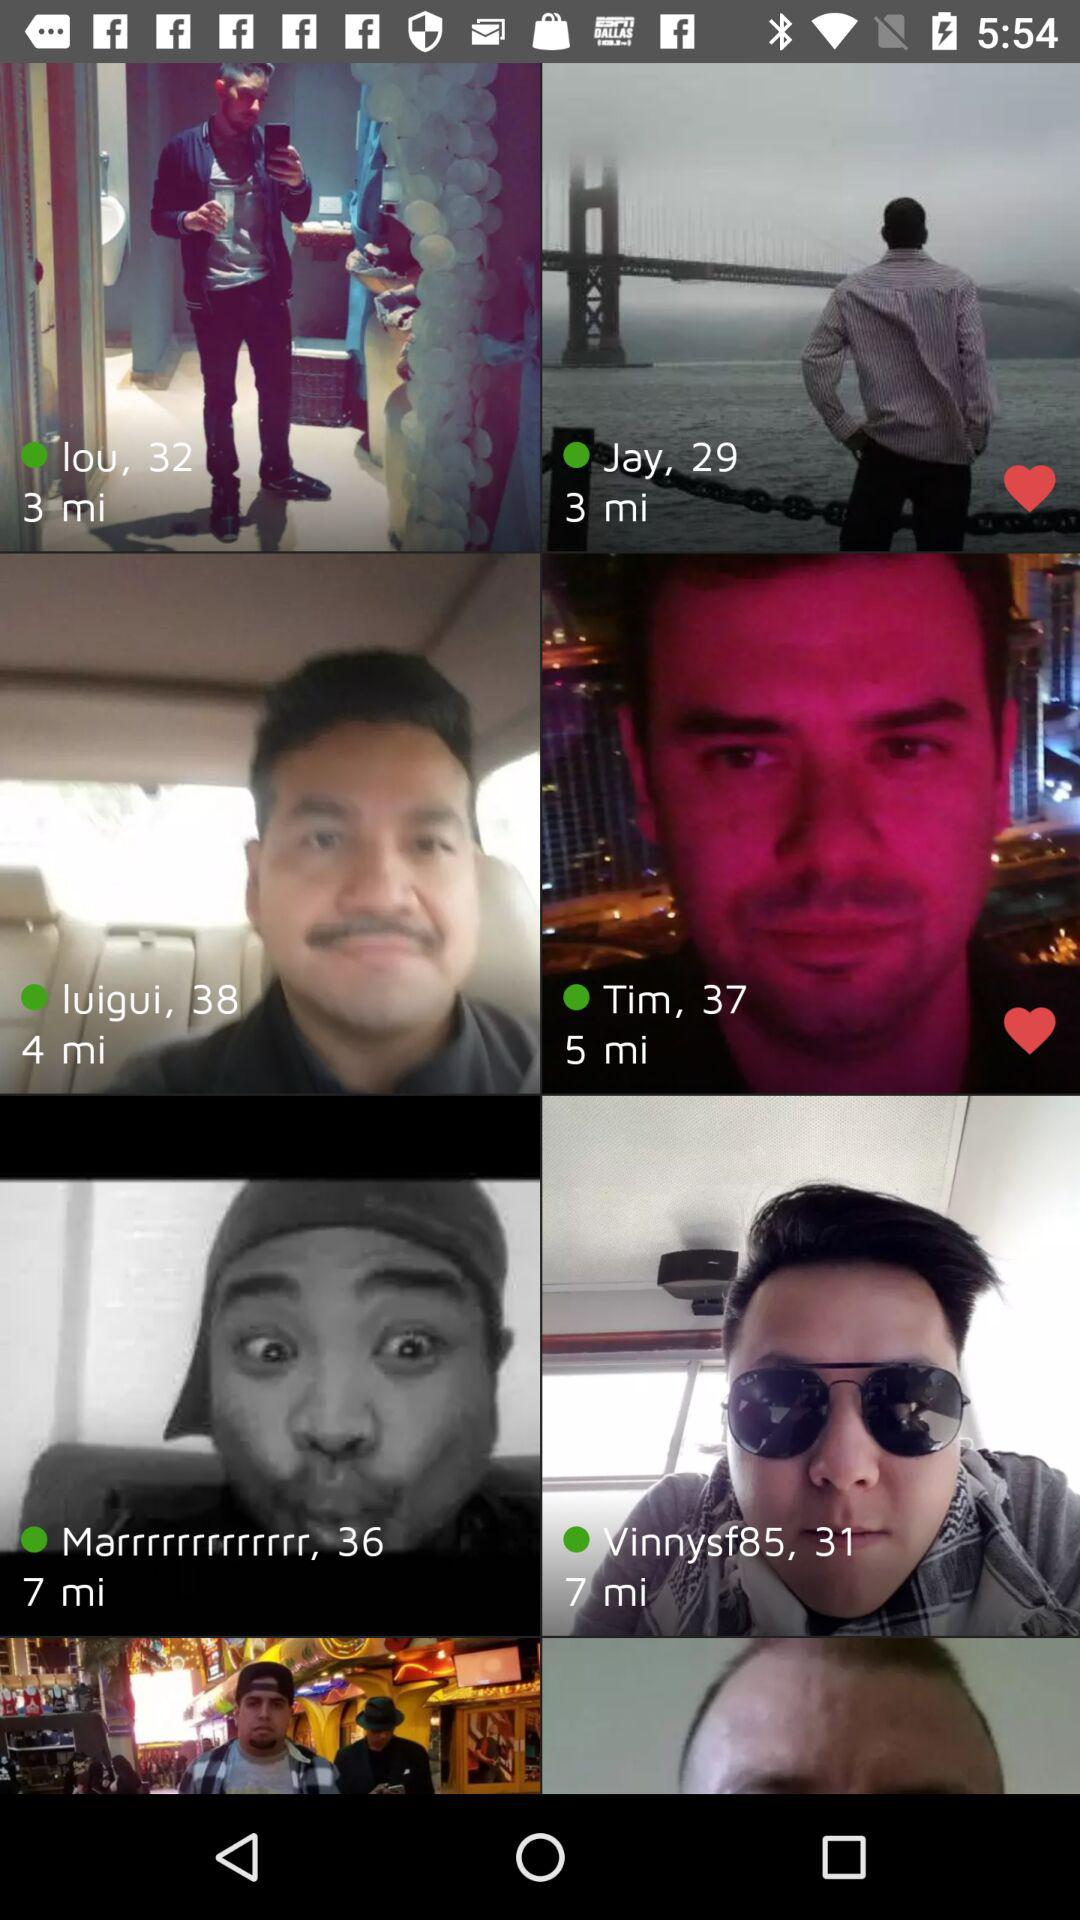What are the names of the people who have been liked? The names of the people who have been liked are Jay and Tim. 